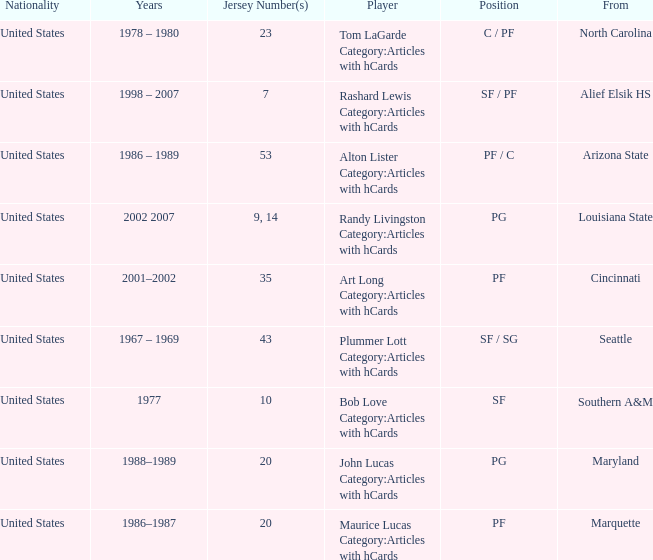Bob Love Category:Articles with hCards is from where? Southern A&M. 